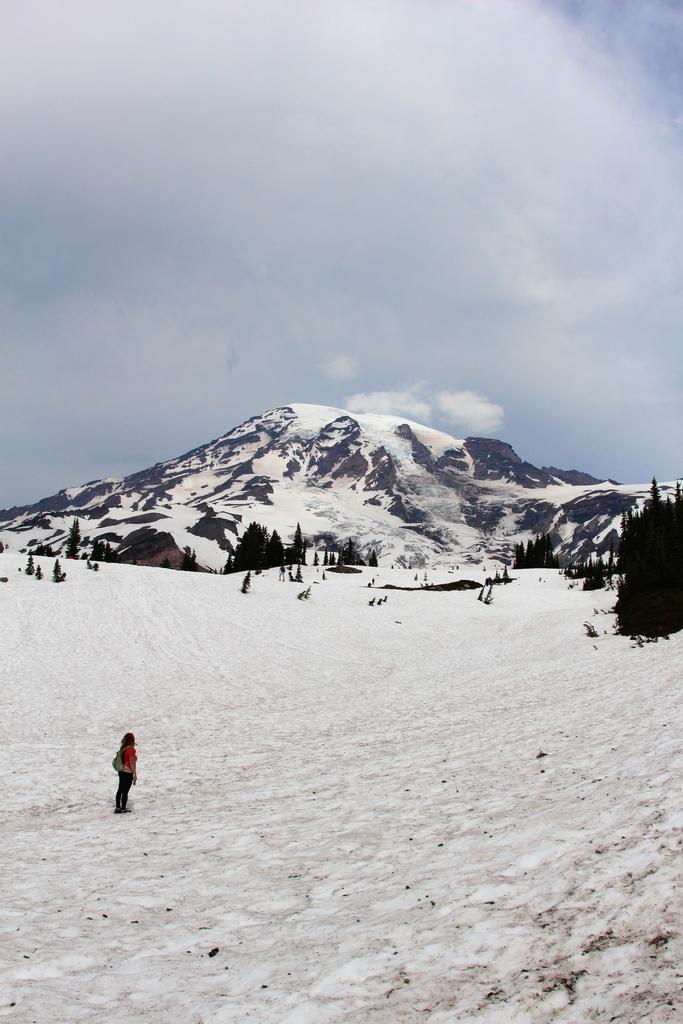In one or two sentences, can you explain what this image depicts? In the picture I can see a person standing on the ice, I can see trees, mountains and the cloudy sky in the background. 